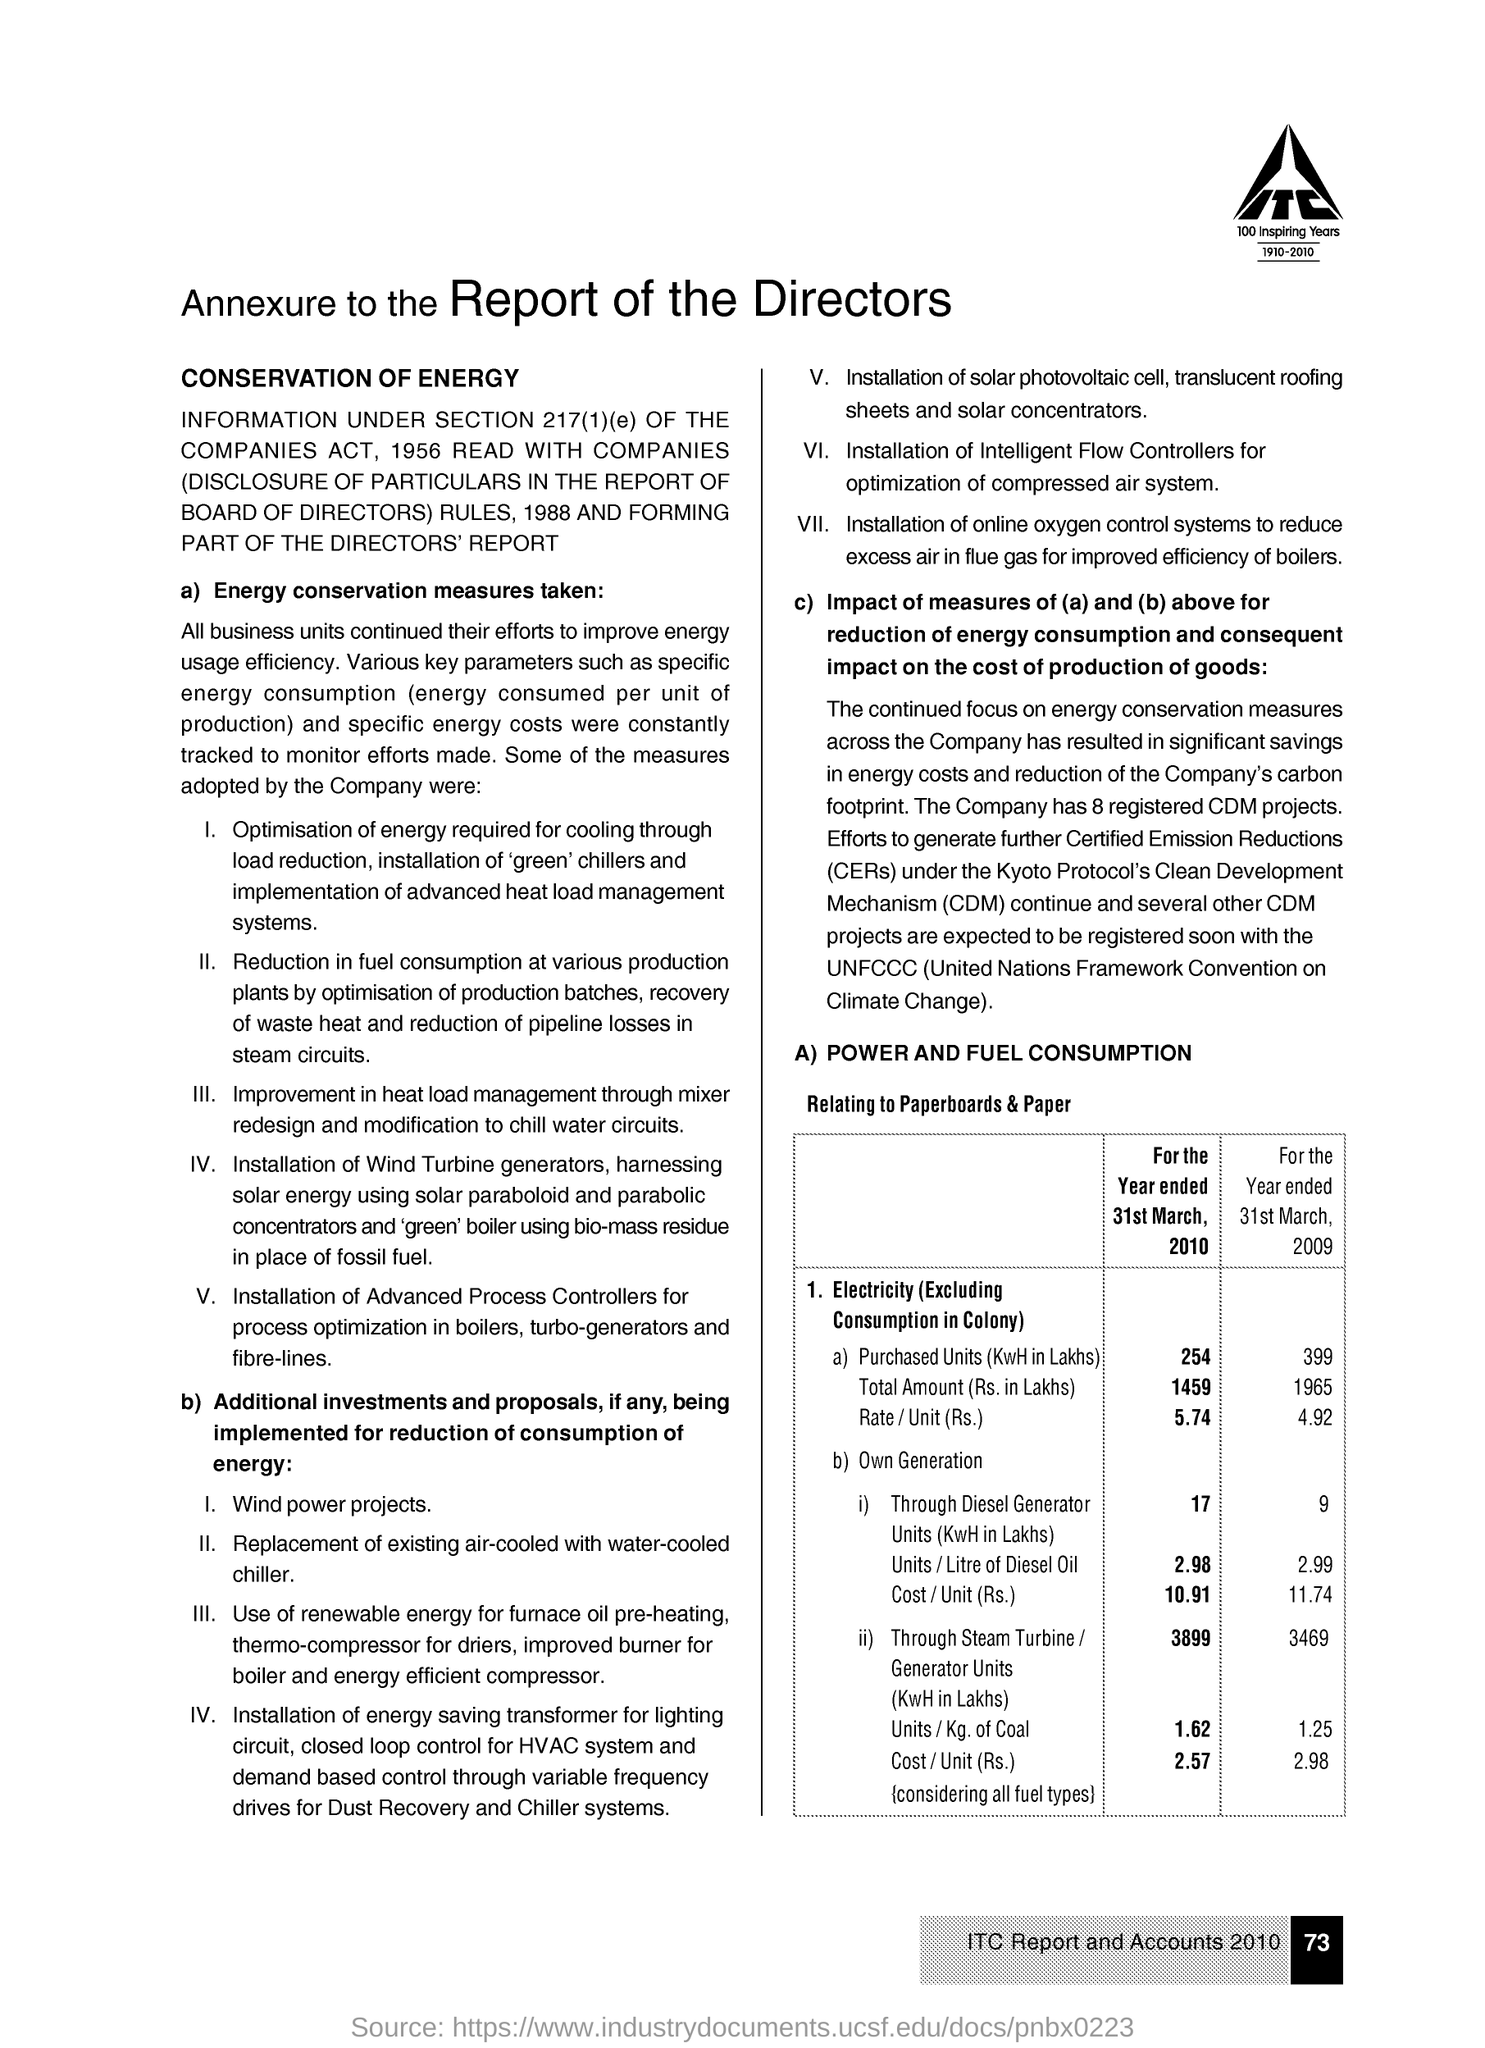Draw attention to some important aspects in this diagram. The amount of purchased units of electricity (excluding consumption in the colony) for the year ended March 31st, 2009, was 399 Lakhs in units of KwH. Certified Emission Reductions, commonly referred to as CERs, are a type of carbon credits that are issued to projects that reduce or remove greenhouse gases from the atmosphere. These credits are certified by a third-party verification body and can be traded on various carbon markets. The Clean Development Mechanism (CDM) is a program established by the United Nations Framework Convention on Climate Change (UNFCCC) that allows countries with high emissions to invest in sustainable development projects in other countries, such as renewable energy projects, in order to earn carbon credits that can be traded or used to offset their own emissions. The total amount of purchased units of electricity (in KwH and excluding consumption in the colony) for the year ended March 31, 2010 was 254 units. The rate of electricity (excluding consumption in the colony) for the year ended 31st March, 2010 was 5.74 rupees per unit. 